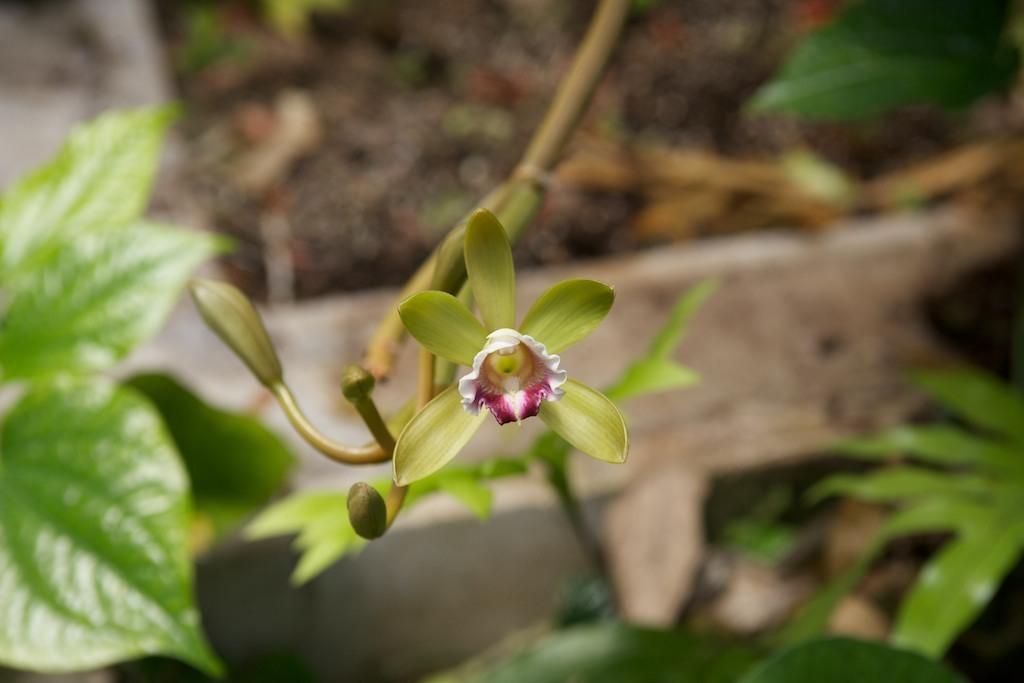How would you summarize this image in a sentence or two? In this image we can see a flower and leaves. 